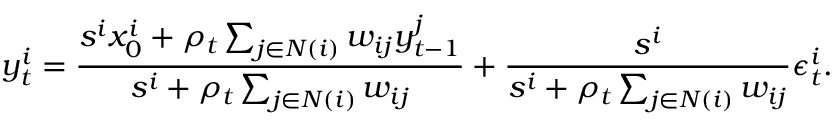Convert formula to latex. <formula><loc_0><loc_0><loc_500><loc_500>y _ { t } ^ { i } = \frac { s ^ { i } x _ { 0 } ^ { i } + \rho _ { t } \sum _ { j \in N ( i ) } w _ { i j } y _ { t - 1 } ^ { j } } { s ^ { i } + \rho _ { t } \sum _ { j \in N ( i ) } w _ { i j } } + \frac { s ^ { i } } { s ^ { i } + \rho _ { t } \sum _ { j \in N ( i ) } w _ { i j } } \epsilon _ { t } ^ { i } .</formula> 